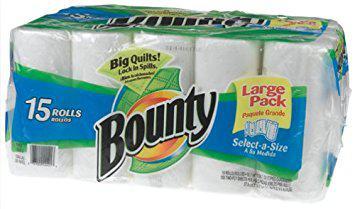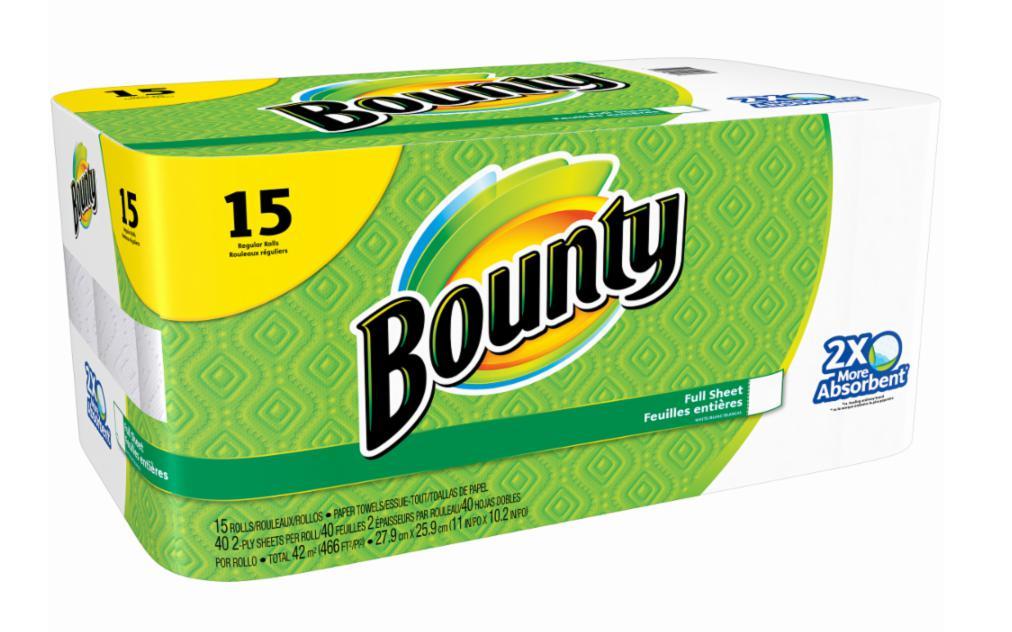The first image is the image on the left, the second image is the image on the right. For the images shown, is this caption "One multipack of towel rolls has a yellow semi-circle in the upper left, and the other multipack has a yellow curved shape with a double-digit number on it." true? Answer yes or no. No. The first image is the image on the left, the second image is the image on the right. For the images shown, is this caption "Every single package of paper towels claims to be 15 rolls worth." true? Answer yes or no. Yes. 